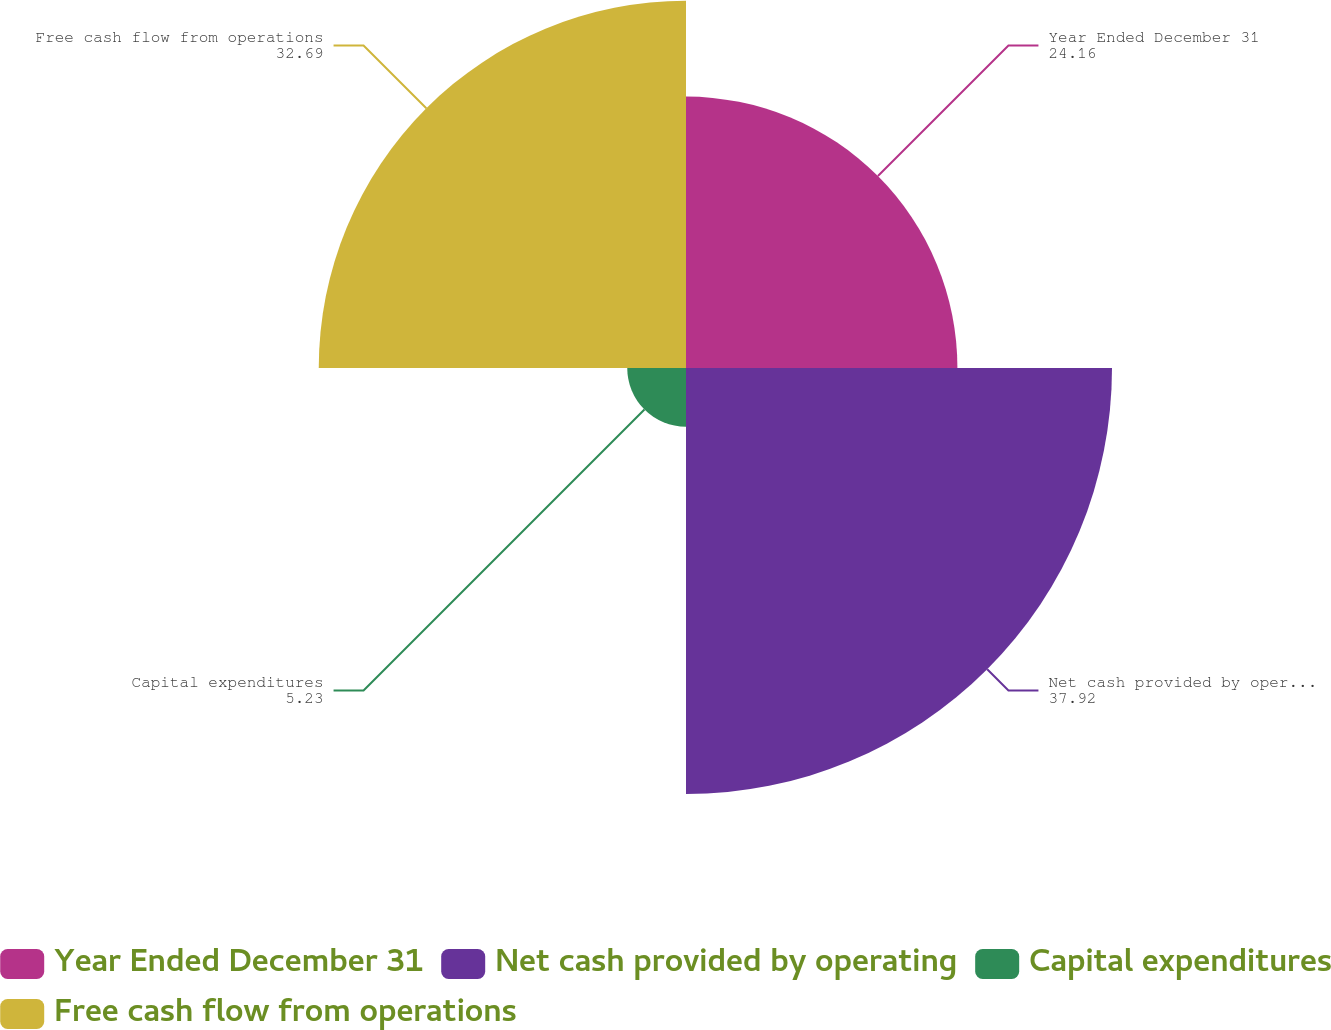<chart> <loc_0><loc_0><loc_500><loc_500><pie_chart><fcel>Year Ended December 31<fcel>Net cash provided by operating<fcel>Capital expenditures<fcel>Free cash flow from operations<nl><fcel>24.16%<fcel>37.92%<fcel>5.23%<fcel>32.69%<nl></chart> 